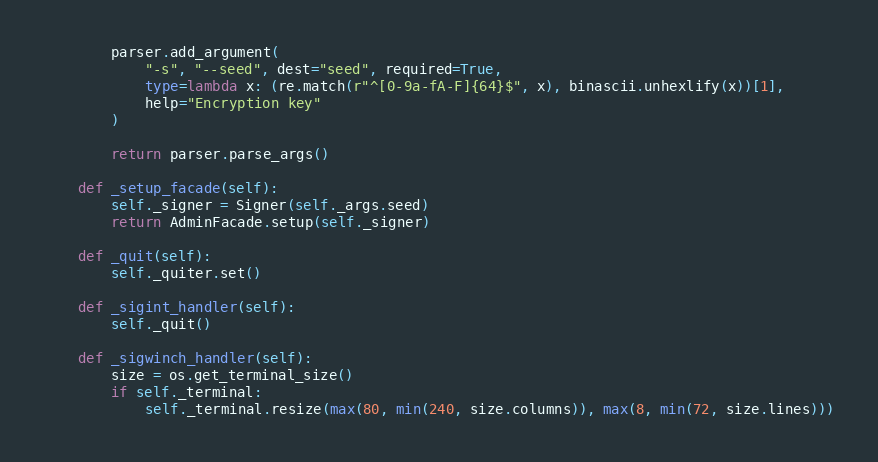Convert code to text. <code><loc_0><loc_0><loc_500><loc_500><_Cython_>        parser.add_argument(
            "-s", "--seed", dest="seed", required=True,
            type=lambda x: (re.match(r"^[0-9a-fA-F]{64}$", x), binascii.unhexlify(x))[1],
            help="Encryption key"
        )

        return parser.parse_args()

    def _setup_facade(self):
        self._signer = Signer(self._args.seed)
        return AdminFacade.setup(self._signer)

    def _quit(self):
        self._quiter.set()

    def _sigint_handler(self):
        self._quit()

    def _sigwinch_handler(self):
        size = os.get_terminal_size()
        if self._terminal:
            self._terminal.resize(max(80, min(240, size.columns)), max(8, min(72, size.lines)))
</code> 